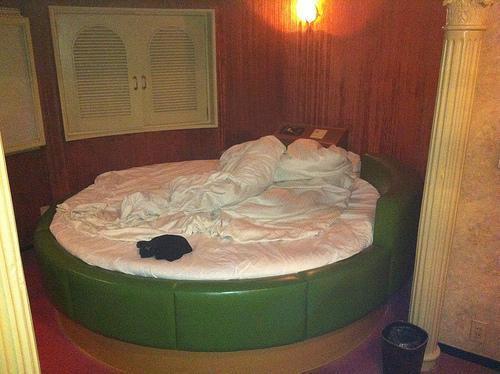How many beds are there?
Give a very brief answer. 1. How many people are in bed?
Give a very brief answer. 1. 